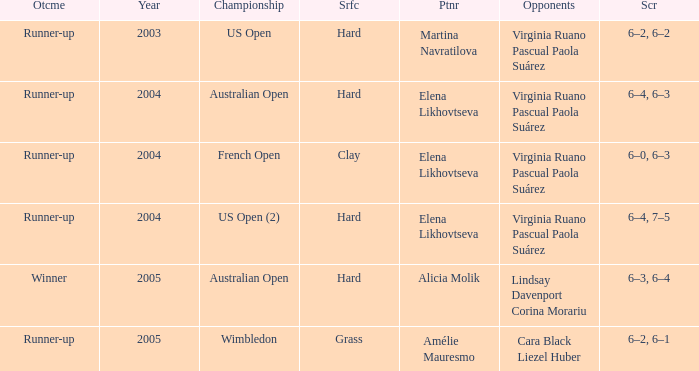When alicia molik is the partner what is the outcome? Winner. 